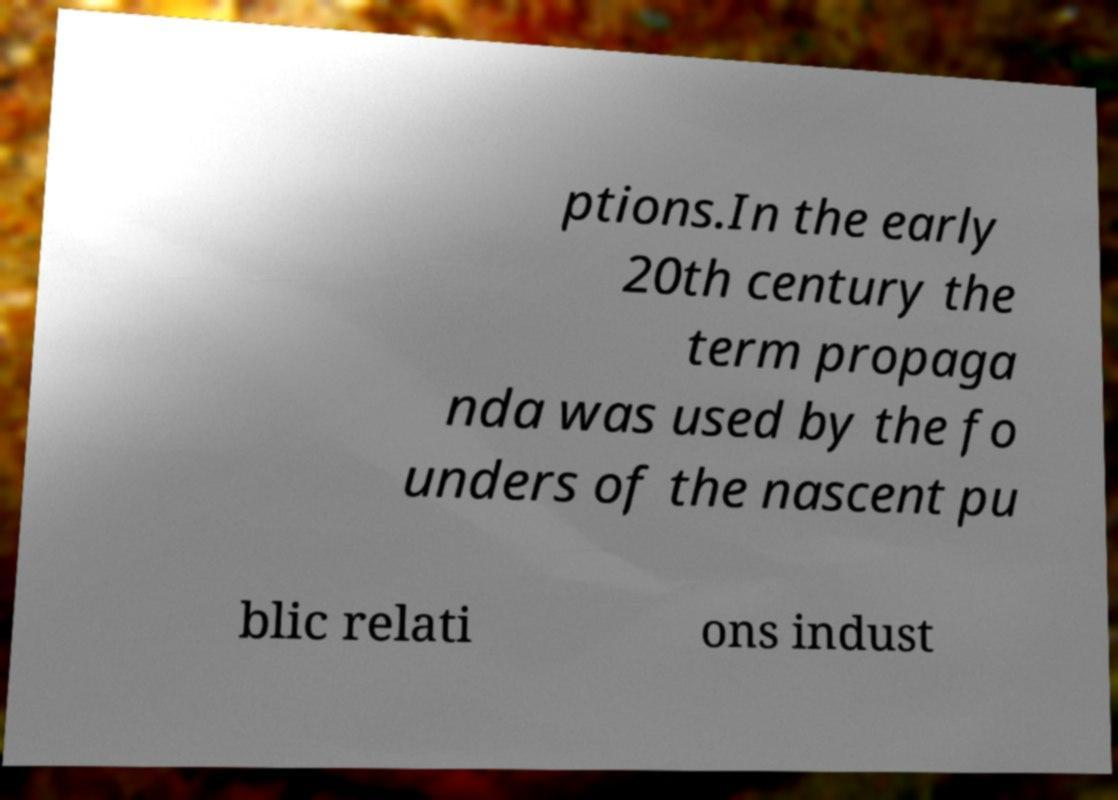There's text embedded in this image that I need extracted. Can you transcribe it verbatim? ptions.In the early 20th century the term propaga nda was used by the fo unders of the nascent pu blic relati ons indust 